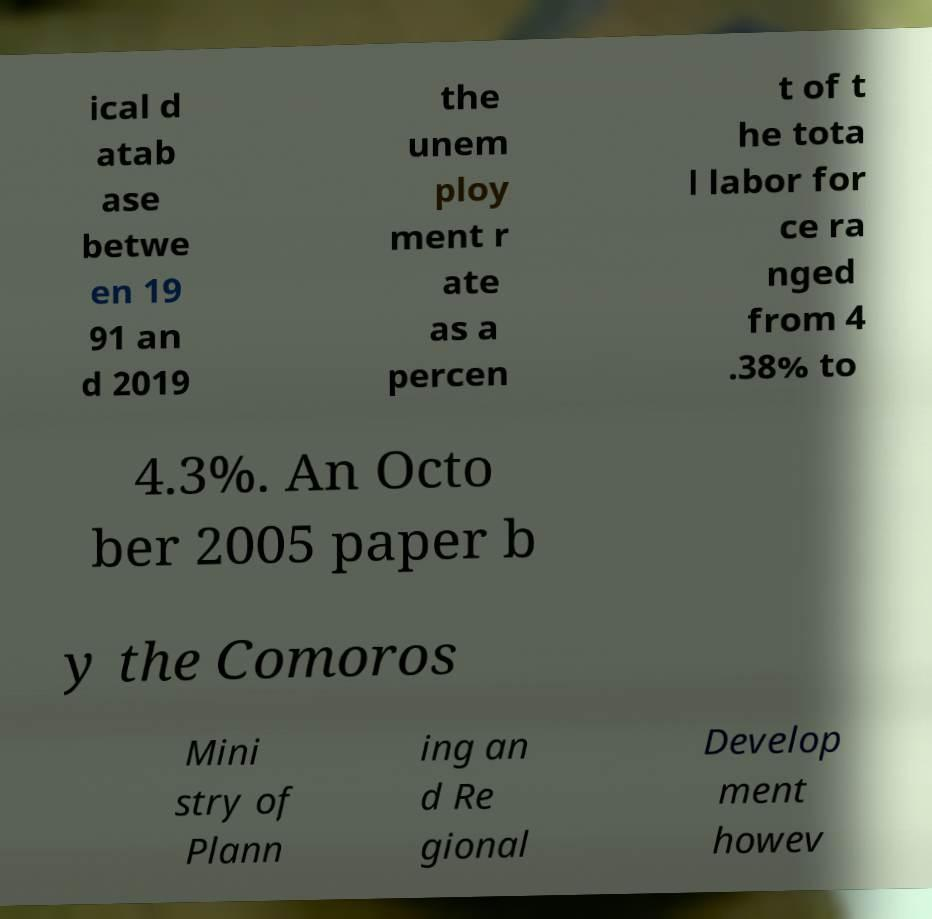Can you accurately transcribe the text from the provided image for me? ical d atab ase betwe en 19 91 an d 2019 the unem ploy ment r ate as a percen t of t he tota l labor for ce ra nged from 4 .38% to 4.3%. An Octo ber 2005 paper b y the Comoros Mini stry of Plann ing an d Re gional Develop ment howev 